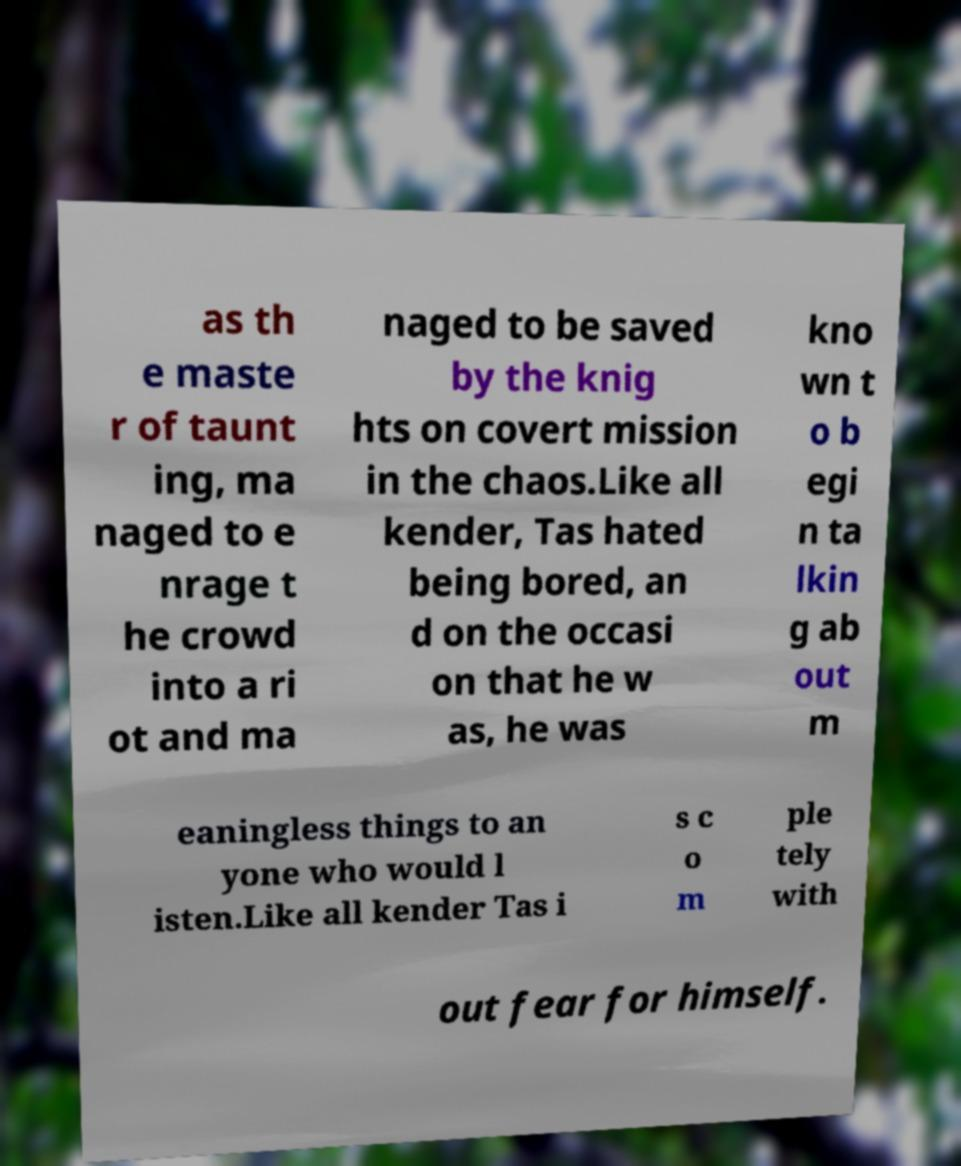I need the written content from this picture converted into text. Can you do that? as th e maste r of taunt ing, ma naged to e nrage t he crowd into a ri ot and ma naged to be saved by the knig hts on covert mission in the chaos.Like all kender, Tas hated being bored, an d on the occasi on that he w as, he was kno wn t o b egi n ta lkin g ab out m eaningless things to an yone who would l isten.Like all kender Tas i s c o m ple tely with out fear for himself. 